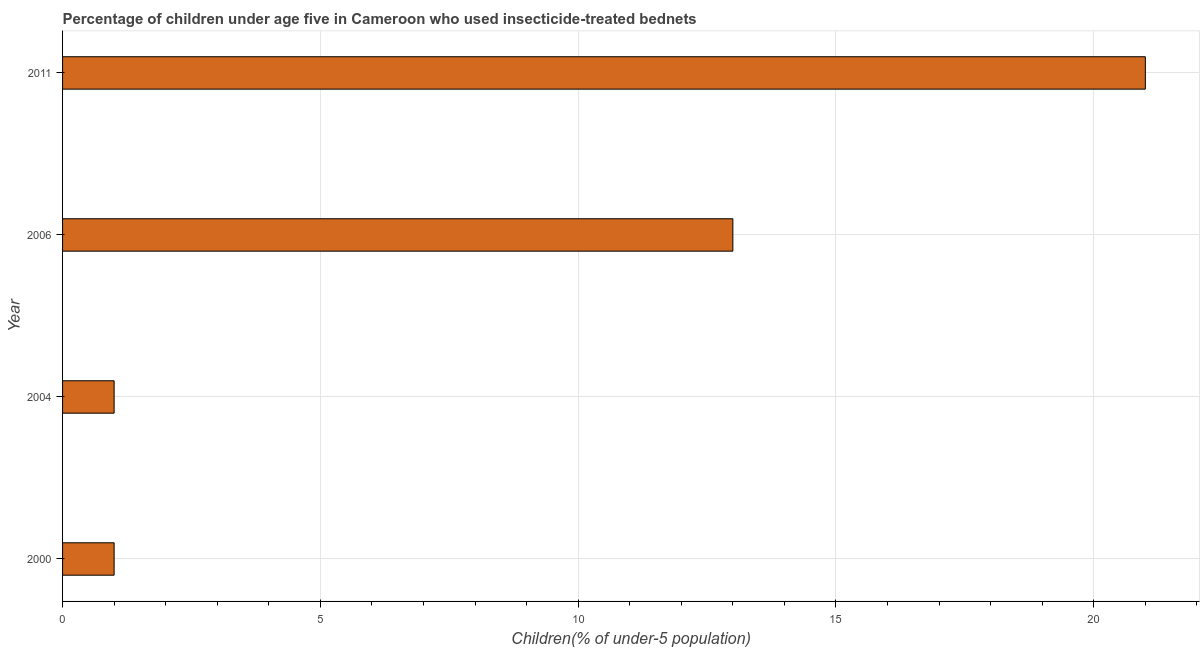Does the graph contain grids?
Your answer should be compact. Yes. What is the title of the graph?
Offer a terse response. Percentage of children under age five in Cameroon who used insecticide-treated bednets. What is the label or title of the X-axis?
Offer a very short reply. Children(% of under-5 population). What is the percentage of children who use of insecticide-treated bed nets in 2006?
Provide a succinct answer. 13. Across all years, what is the maximum percentage of children who use of insecticide-treated bed nets?
Keep it short and to the point. 21. Across all years, what is the minimum percentage of children who use of insecticide-treated bed nets?
Provide a succinct answer. 1. In which year was the percentage of children who use of insecticide-treated bed nets minimum?
Make the answer very short. 2000. What is the median percentage of children who use of insecticide-treated bed nets?
Your answer should be compact. 7. In how many years, is the percentage of children who use of insecticide-treated bed nets greater than 16 %?
Give a very brief answer. 1. Do a majority of the years between 2011 and 2006 (inclusive) have percentage of children who use of insecticide-treated bed nets greater than 20 %?
Keep it short and to the point. No. What is the ratio of the percentage of children who use of insecticide-treated bed nets in 2006 to that in 2011?
Give a very brief answer. 0.62. What is the difference between the highest and the second highest percentage of children who use of insecticide-treated bed nets?
Provide a short and direct response. 8. What is the difference between the highest and the lowest percentage of children who use of insecticide-treated bed nets?
Make the answer very short. 20. How many bars are there?
Provide a short and direct response. 4. Are all the bars in the graph horizontal?
Your answer should be compact. Yes. What is the Children(% of under-5 population) of 2006?
Your answer should be compact. 13. What is the Children(% of under-5 population) of 2011?
Make the answer very short. 21. What is the difference between the Children(% of under-5 population) in 2000 and 2006?
Ensure brevity in your answer.  -12. What is the difference between the Children(% of under-5 population) in 2004 and 2006?
Your answer should be very brief. -12. What is the difference between the Children(% of under-5 population) in 2004 and 2011?
Your response must be concise. -20. What is the difference between the Children(% of under-5 population) in 2006 and 2011?
Give a very brief answer. -8. What is the ratio of the Children(% of under-5 population) in 2000 to that in 2004?
Your answer should be compact. 1. What is the ratio of the Children(% of under-5 population) in 2000 to that in 2006?
Give a very brief answer. 0.08. What is the ratio of the Children(% of under-5 population) in 2000 to that in 2011?
Provide a short and direct response. 0.05. What is the ratio of the Children(% of under-5 population) in 2004 to that in 2006?
Your response must be concise. 0.08. What is the ratio of the Children(% of under-5 population) in 2004 to that in 2011?
Ensure brevity in your answer.  0.05. What is the ratio of the Children(% of under-5 population) in 2006 to that in 2011?
Keep it short and to the point. 0.62. 